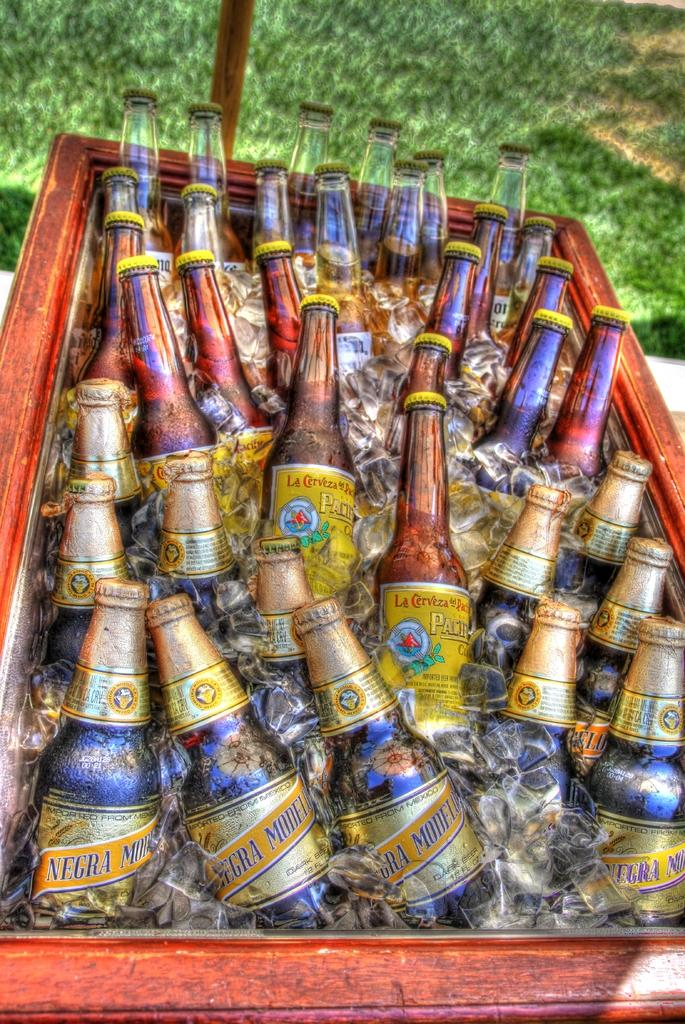<image>
Relay a brief, clear account of the picture shown. Negra Modelo beer bottles and other beer bottles are in a container of ice. 